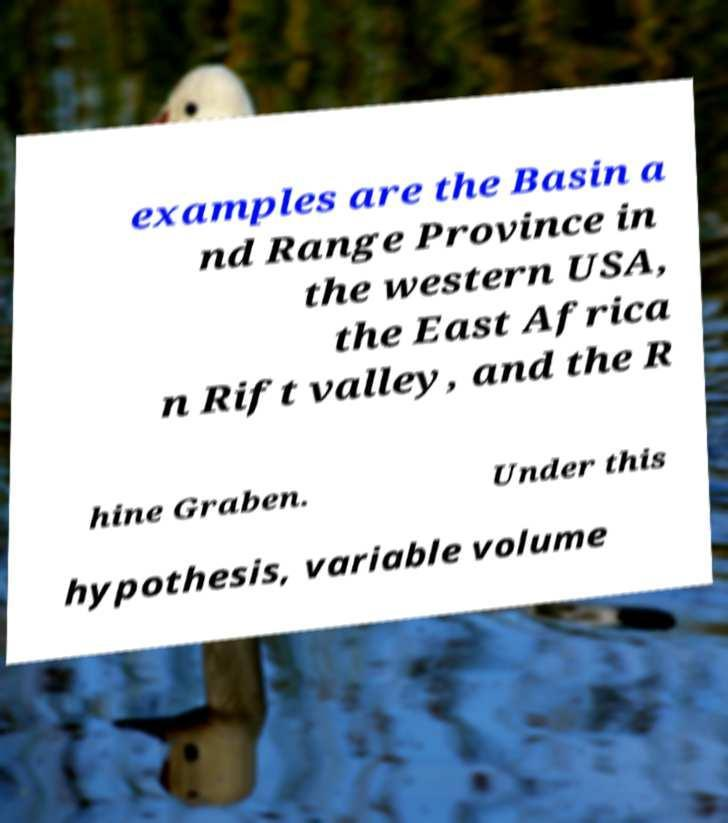Please identify and transcribe the text found in this image. examples are the Basin a nd Range Province in the western USA, the East Africa n Rift valley, and the R hine Graben. Under this hypothesis, variable volume 